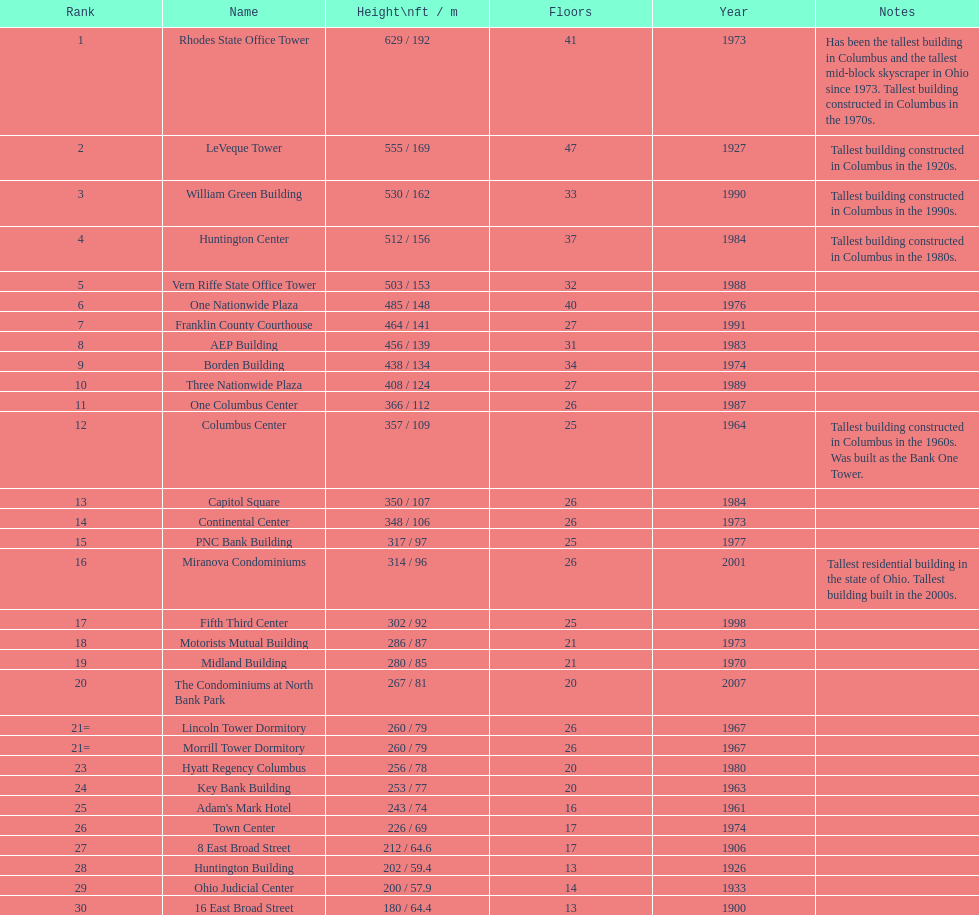Which edifices are over 500 ft tall? Rhodes State Office Tower, LeVeque Tower, William Green Building, Huntington Center, Vern Riffe State Office Tower. 